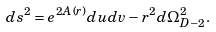<formula> <loc_0><loc_0><loc_500><loc_500>d s ^ { 2 } = e ^ { 2 A ( r ) } d u d v - r ^ { 2 } d \Omega ^ { 2 } _ { D - 2 } . \label a { t w o d i m e n s i o n a l m e t r i c }</formula> 